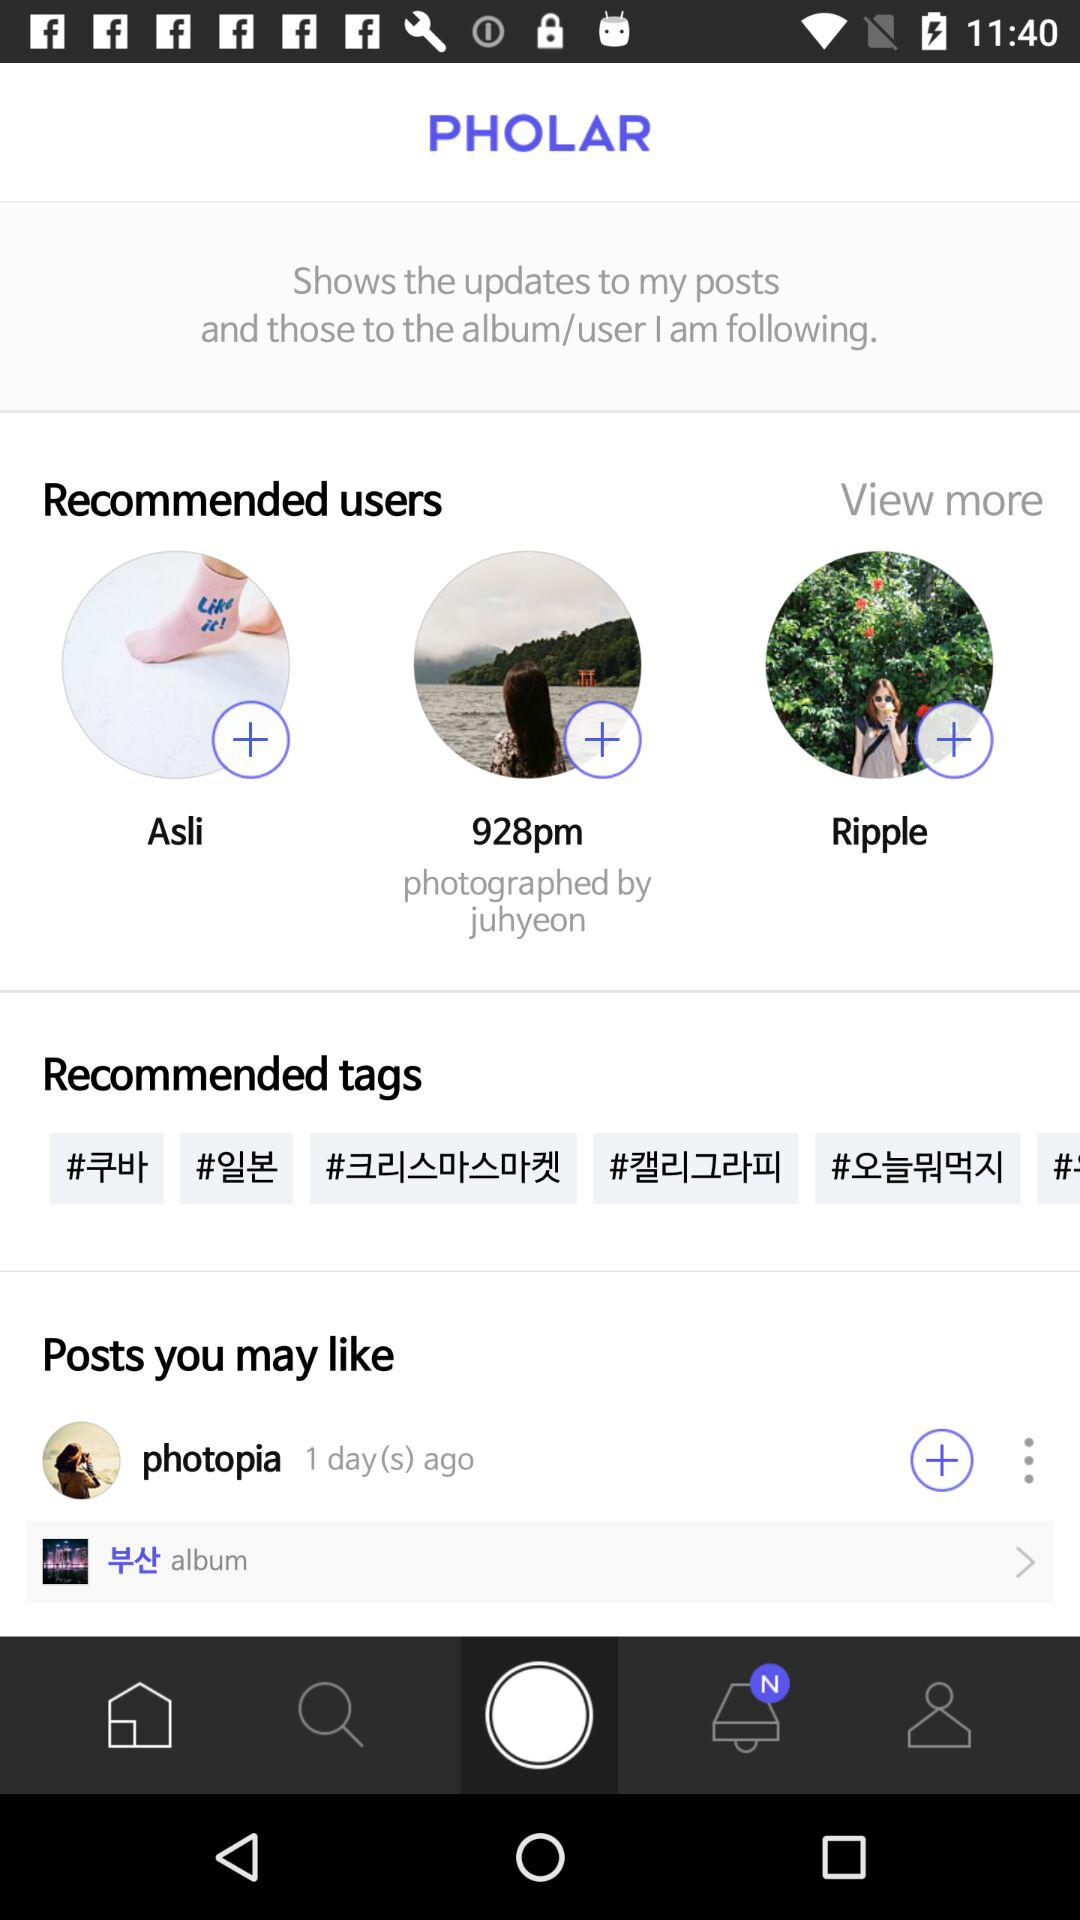What are the names of the recommended users? The names of the recommended users are Asli, "928pm" and Ripple. 